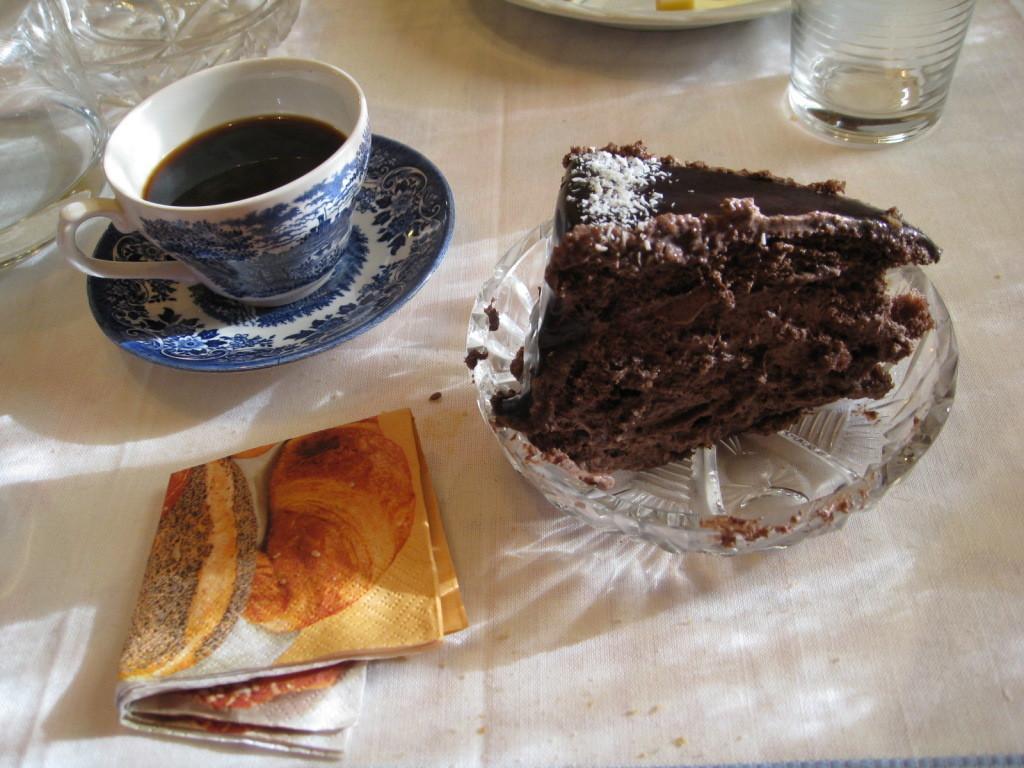How would you summarize this image in a sentence or two? In this image there is a table and we can see plates, cup, saucer, glass, napkin and a cake placed on the table. 